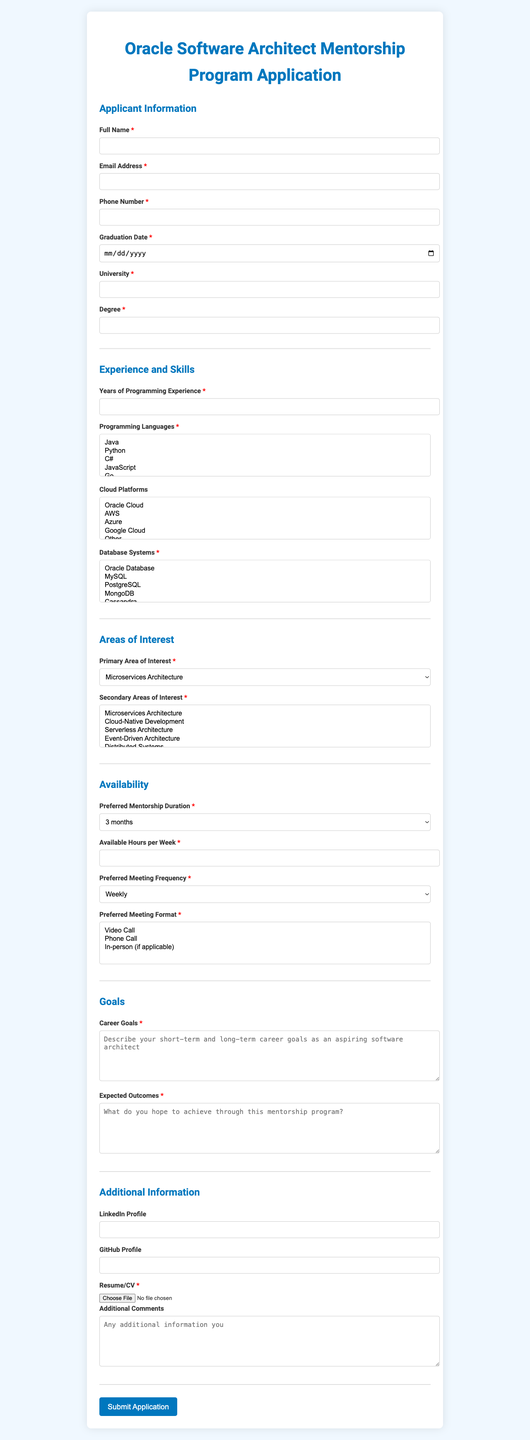What is the title of the application form? The title is stated at the beginning of the document.
Answer: Oracle Software Architect Mentorship Program Application How many years of programming experience is asked for? The document explicitly asks for the number of years of programming experience as a numeric input.
Answer: Number What is the maximum number of secondary areas of interest one can select? The document mentions a limitation on the number of selections for secondary areas of interest.
Answer: 3 What is the required format for the resume/CV? The document specifies accepted formats for the resume/CV upload in the additional information section.
Answer: .pdf, .doc, .docx What is the primary area of interest selection? The document lists the primary area of interest as a dropdown selection.
Answer: Microservices Architecture, Cloud-Native Development, Serverless Architecture, Event-Driven Architecture, Distributed Systems, API Design and Management, Data Architecture, DevOps and CI/CD, Containerization and Orchestration, Security Architecture What kind of meeting format is preferred for the mentorship? The document provides options for the format of the meeting under the availability section.
Answer: Video Call, Phone Call, In-person (if applicable) Which cloud platforms are mentioned as options in the form? The document lists cloud platforms available for selection in the experience and skills section.
Answer: Oracle Cloud, AWS, Azure, Google Cloud, Other Why is a GitHub profile an optional field? The document includes the GitHub profile as additional information rather than required information, making it optional.
Answer: Optional 